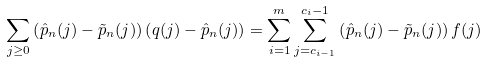<formula> <loc_0><loc_0><loc_500><loc_500>\sum _ { j \geq 0 } \left ( \hat { p } _ { n } ( j ) - \tilde { p } _ { n } ( j ) \right ) \left ( q ( j ) - \hat { p } _ { n } ( j ) \right ) = \sum _ { i = 1 } ^ { m } \sum _ { j = c _ { i - 1 } } ^ { c _ { i } - 1 } \left ( \hat { p } _ { n } ( j ) - \tilde { p } _ { n } ( j ) \right ) f ( j )</formula> 